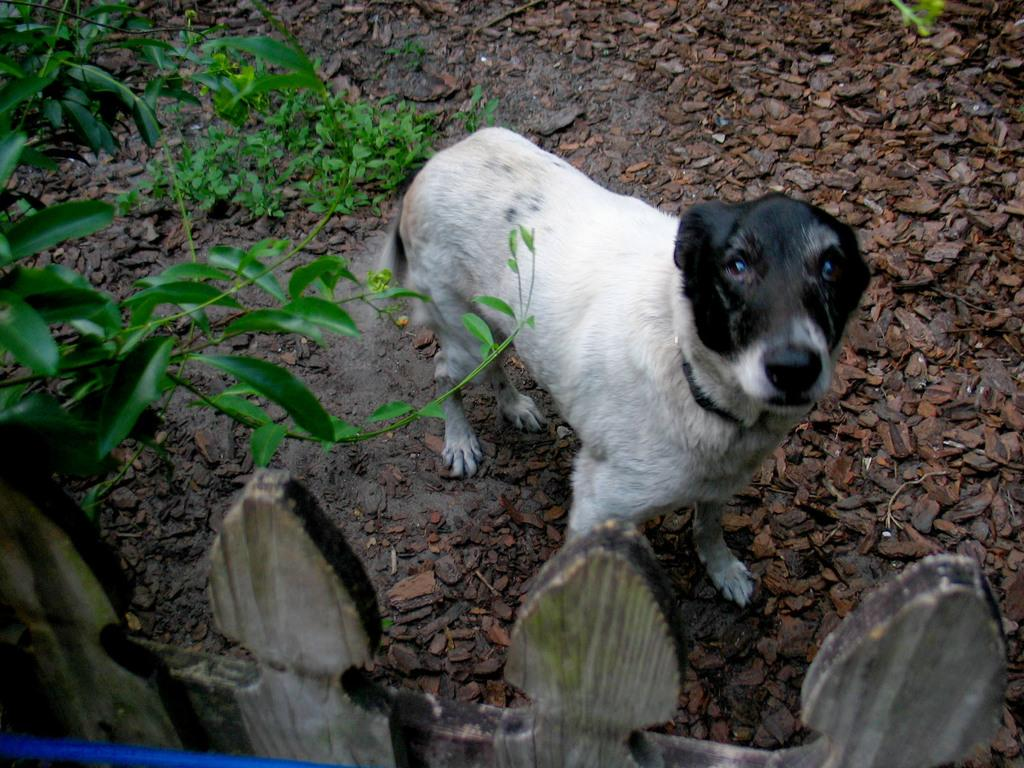What type of animal is in the image? There is a dog in the image. Where is the dog located? The dog is on the ground. What can be seen in the image besides the dog? There are plants and leaves present in the image. What type of barrier is visible in the image? There is a fence in the image. Can you describe the object in the image? Unfortunately, the facts provided do not give enough information to describe the object in the image. How many children are offering the dog a treat in the image? There are no children present in the image, and therefore no one is offering the dog a treat. 